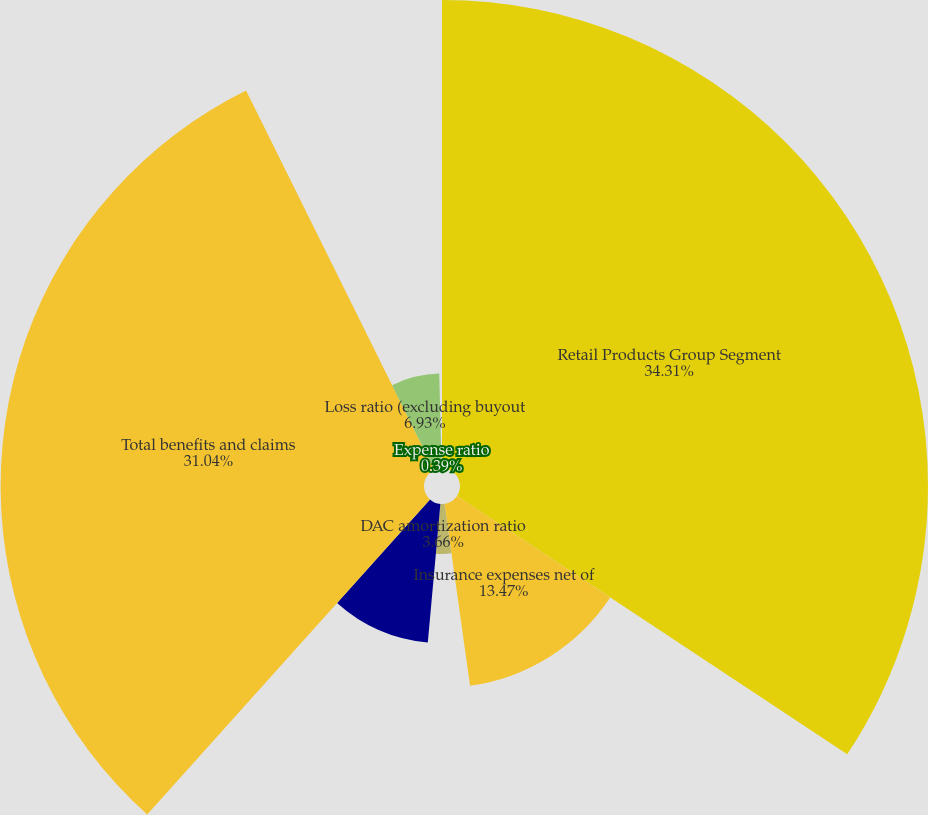Convert chart. <chart><loc_0><loc_0><loc_500><loc_500><pie_chart><fcel>Retail Products Group Segment<fcel>Insurance expenses net of<fcel>DAC amortization ratio<fcel>Death benefits<fcel>Total benefits and claims<fcel>Loss ratio (excluding buyout<fcel>Expense ratio<nl><fcel>34.31%<fcel>13.47%<fcel>3.66%<fcel>10.2%<fcel>31.04%<fcel>6.93%<fcel>0.39%<nl></chart> 